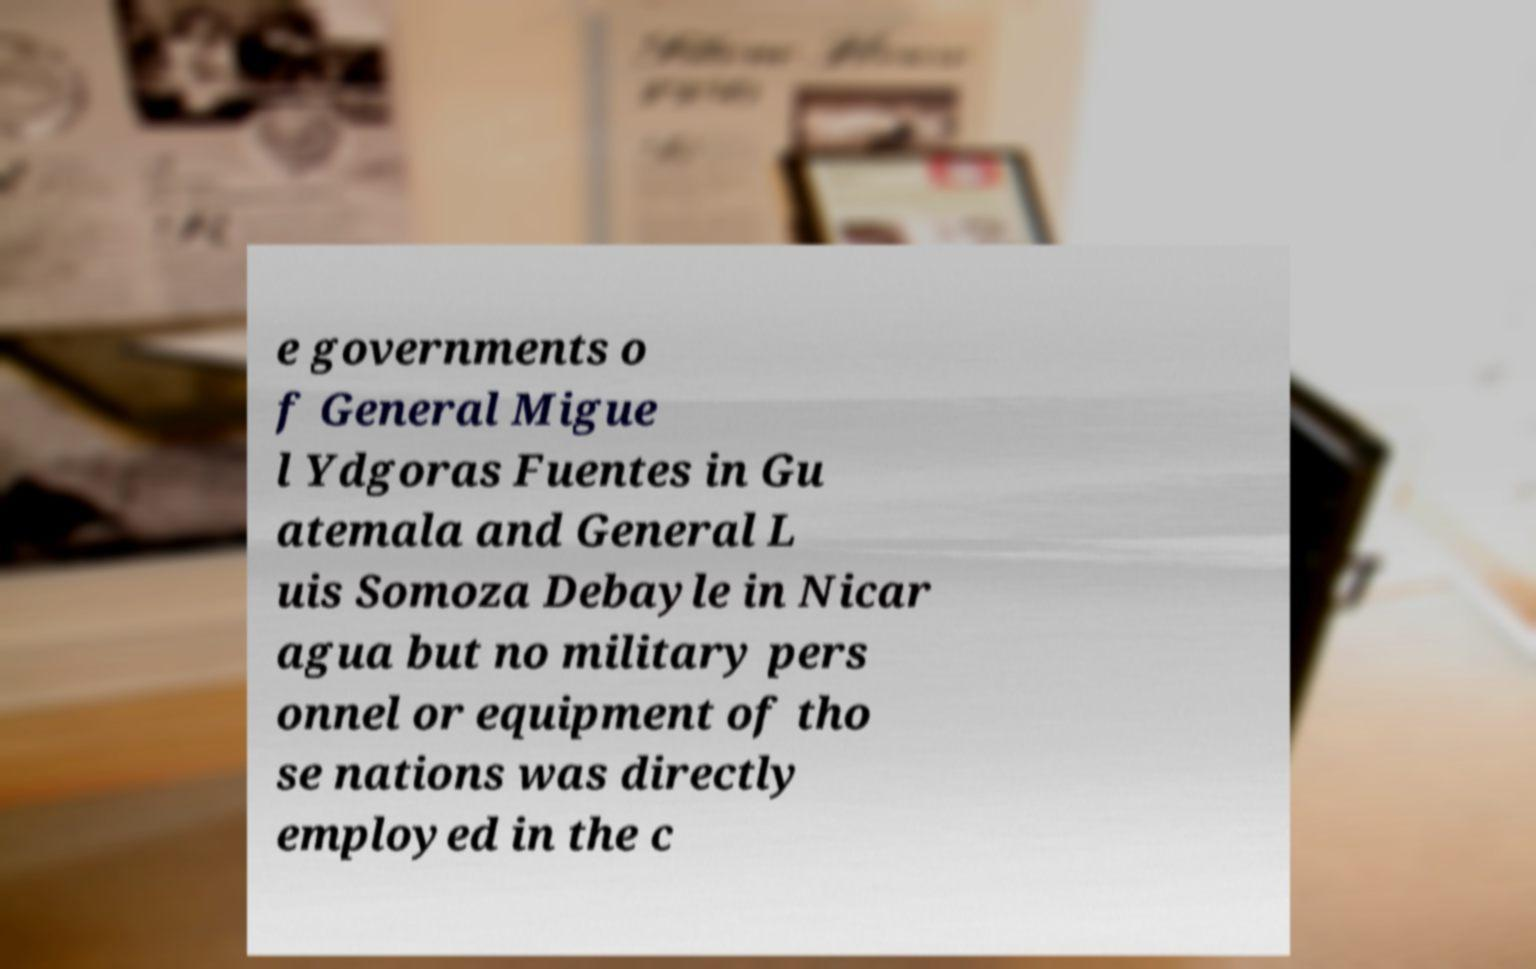Could you extract and type out the text from this image? e governments o f General Migue l Ydgoras Fuentes in Gu atemala and General L uis Somoza Debayle in Nicar agua but no military pers onnel or equipment of tho se nations was directly employed in the c 